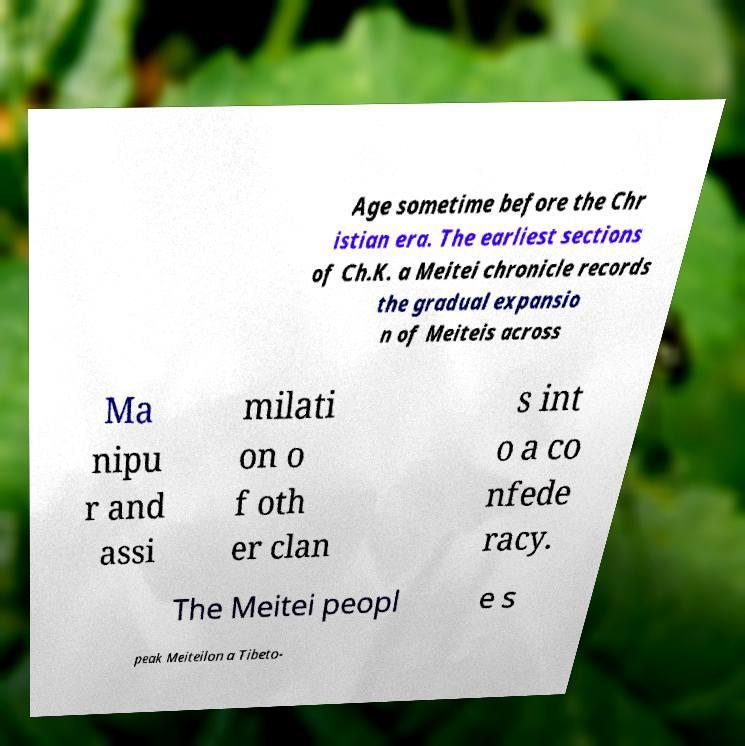Could you extract and type out the text from this image? Age sometime before the Chr istian era. The earliest sections of Ch.K. a Meitei chronicle records the gradual expansio n of Meiteis across Ma nipu r and assi milati on o f oth er clan s int o a co nfede racy. The Meitei peopl e s peak Meiteilon a Tibeto- 